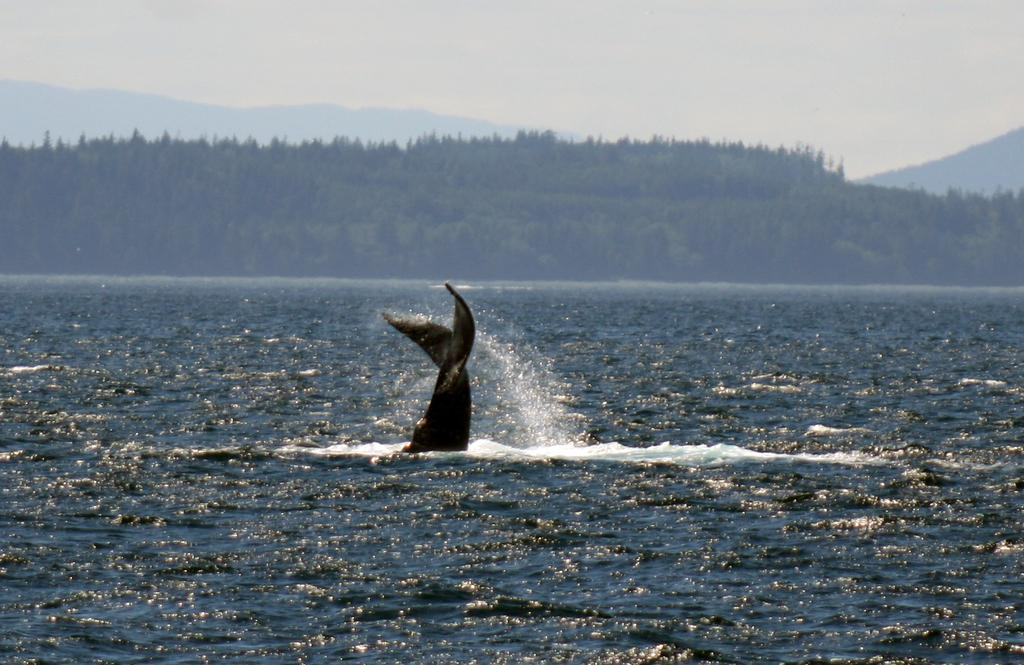What animal is in the water in the image? There is a dolphin in the water in the image. What type of vegetation can be seen in the background of the image? There are trees in the background of the image. What type of geographical feature is visible in the background of the image? There are mountains in the background of the image. What part of the natural environment is visible in the background of the image? The sky is visible in the background of the image. What type of brush is being used by the dolphin in the image? There is no brush present in the image, and the dolphin is not using any tool or object. 